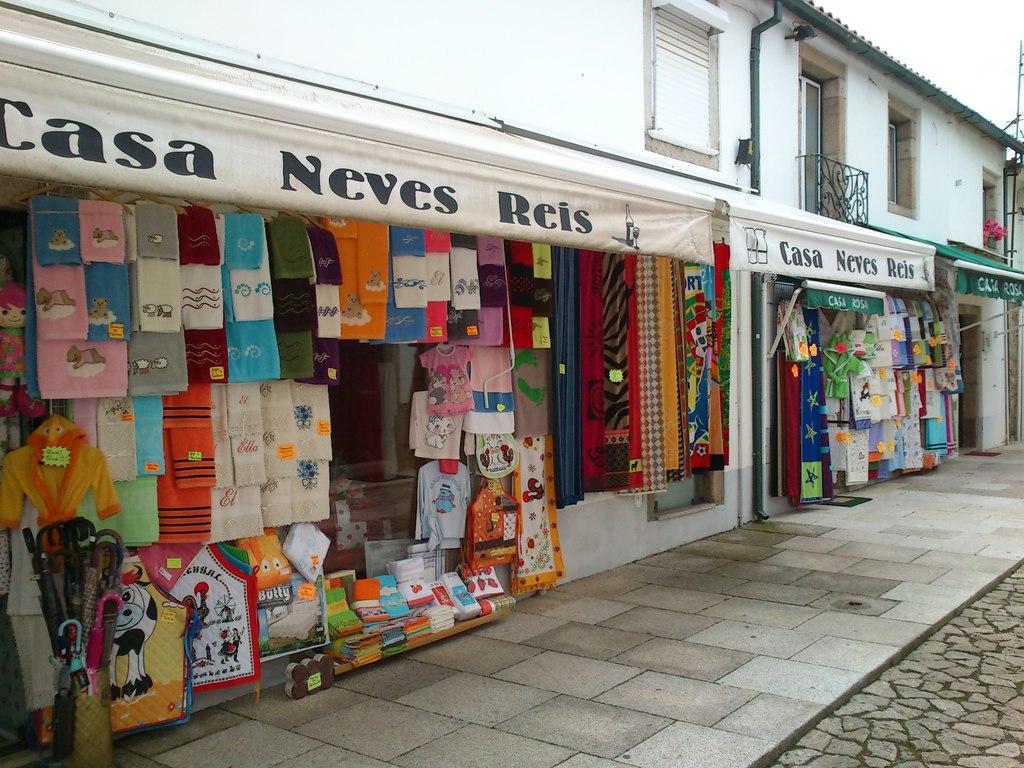What is the name of this store?
Provide a short and direct response. Casa neves reis. What word begins with c in the store name?
Offer a very short reply. Casa. 